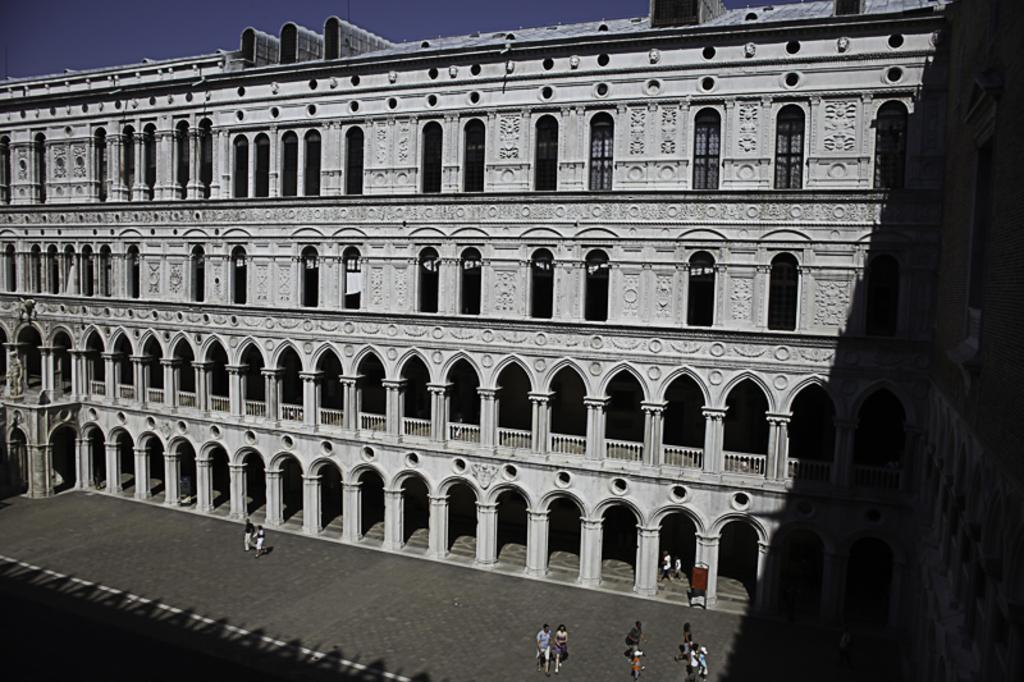What type of structure is present in the image? There is a building in the image. What feature can be seen on the building? The building has windows. What activity are the people in the image engaged in? There are people walking in the image. What is visible at the top of the image? The sky is visible at the top of the image. What type of corn can be seen growing on the building in the image? There is no corn present in the image, and the building does not have any corn growing on it. 